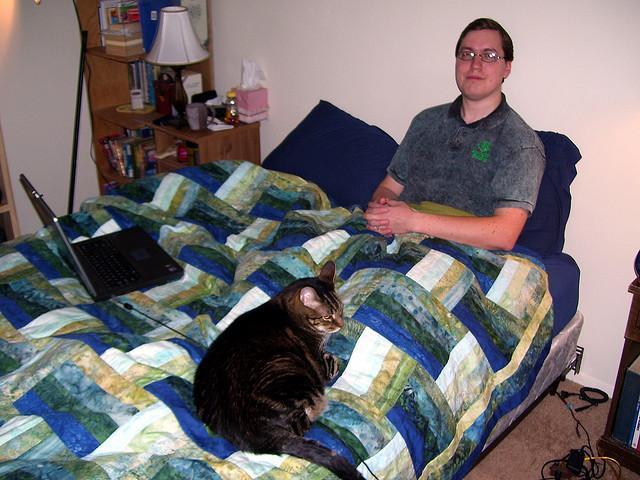How many people are in the picture?
Give a very brief answer. 1. How many beds are in the picture?
Give a very brief answer. 1. How many laptops are visible?
Give a very brief answer. 1. 